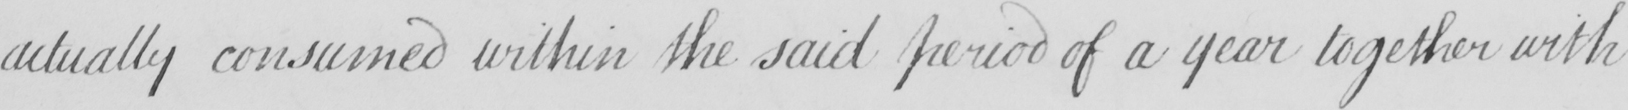Transcribe the text shown in this historical manuscript line. actually consumed within the said period of a year together with 